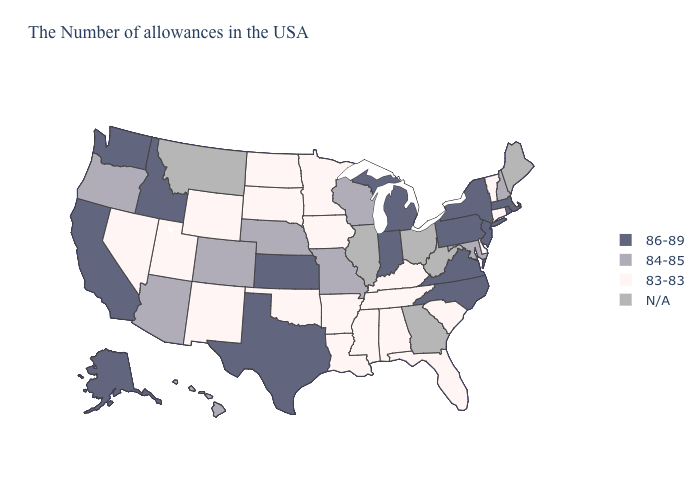Among the states that border Colorado , which have the highest value?
Keep it brief. Kansas. What is the highest value in the West ?
Give a very brief answer. 86-89. Is the legend a continuous bar?
Answer briefly. No. Does Arizona have the highest value in the USA?
Give a very brief answer. No. Name the states that have a value in the range 83-83?
Write a very short answer. Vermont, Connecticut, Delaware, South Carolina, Florida, Kentucky, Alabama, Tennessee, Mississippi, Louisiana, Arkansas, Minnesota, Iowa, Oklahoma, South Dakota, North Dakota, Wyoming, New Mexico, Utah, Nevada. Does Virginia have the highest value in the South?
Short answer required. Yes. What is the highest value in states that border Oklahoma?
Keep it brief. 86-89. Name the states that have a value in the range 86-89?
Short answer required. Massachusetts, Rhode Island, New York, New Jersey, Pennsylvania, Virginia, North Carolina, Michigan, Indiana, Kansas, Texas, Idaho, California, Washington, Alaska. What is the highest value in the USA?
Concise answer only. 86-89. Name the states that have a value in the range 84-85?
Give a very brief answer. New Hampshire, Maryland, Wisconsin, Missouri, Nebraska, Colorado, Arizona, Oregon, Hawaii. Name the states that have a value in the range 84-85?
Concise answer only. New Hampshire, Maryland, Wisconsin, Missouri, Nebraska, Colorado, Arizona, Oregon, Hawaii. Name the states that have a value in the range 83-83?
Be succinct. Vermont, Connecticut, Delaware, South Carolina, Florida, Kentucky, Alabama, Tennessee, Mississippi, Louisiana, Arkansas, Minnesota, Iowa, Oklahoma, South Dakota, North Dakota, Wyoming, New Mexico, Utah, Nevada. Which states have the lowest value in the MidWest?
Answer briefly. Minnesota, Iowa, South Dakota, North Dakota. Which states have the lowest value in the MidWest?
Keep it brief. Minnesota, Iowa, South Dakota, North Dakota. Which states have the lowest value in the South?
Keep it brief. Delaware, South Carolina, Florida, Kentucky, Alabama, Tennessee, Mississippi, Louisiana, Arkansas, Oklahoma. 